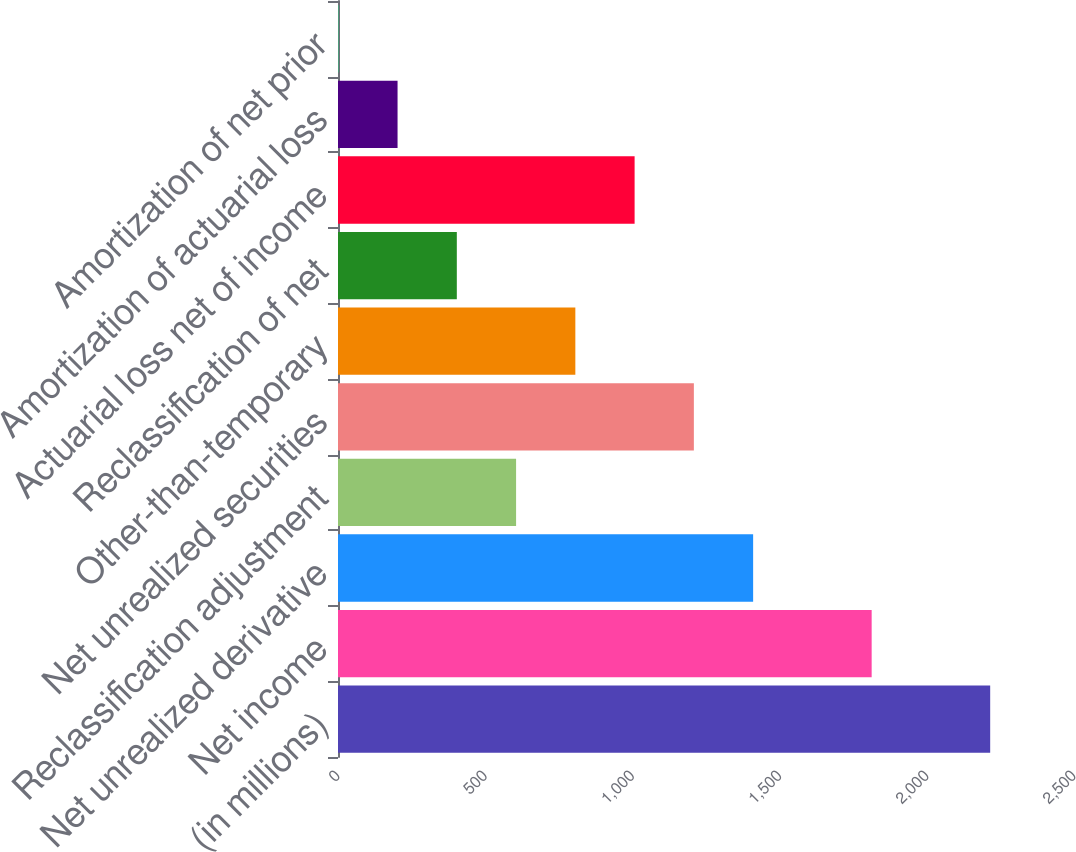Convert chart to OTSL. <chart><loc_0><loc_0><loc_500><loc_500><bar_chart><fcel>(in millions)<fcel>Net income<fcel>Net unrealized derivative<fcel>Reclassification adjustment<fcel>Net unrealized securities<fcel>Other-than-temporary<fcel>Reclassification of net<fcel>Actuarial loss net of income<fcel>Amortization of actuarial loss<fcel>Amortization of net prior<nl><fcel>2215.3<fcel>1812.7<fcel>1410.1<fcel>604.9<fcel>1208.8<fcel>806.2<fcel>403.6<fcel>1007.5<fcel>202.3<fcel>1<nl></chart> 